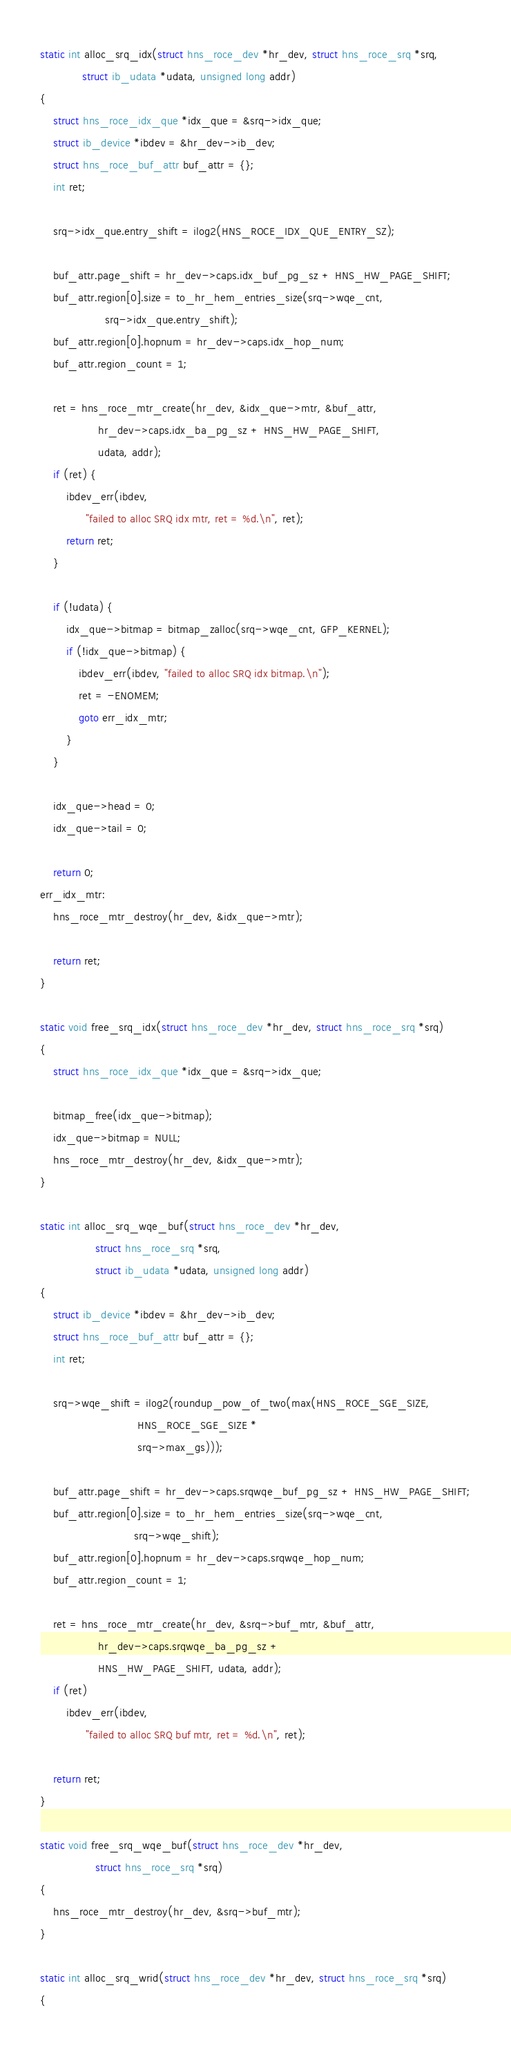<code> <loc_0><loc_0><loc_500><loc_500><_C_>
static int alloc_srq_idx(struct hns_roce_dev *hr_dev, struct hns_roce_srq *srq,
			 struct ib_udata *udata, unsigned long addr)
{
	struct hns_roce_idx_que *idx_que = &srq->idx_que;
	struct ib_device *ibdev = &hr_dev->ib_dev;
	struct hns_roce_buf_attr buf_attr = {};
	int ret;

	srq->idx_que.entry_shift = ilog2(HNS_ROCE_IDX_QUE_ENTRY_SZ);

	buf_attr.page_shift = hr_dev->caps.idx_buf_pg_sz + HNS_HW_PAGE_SHIFT;
	buf_attr.region[0].size = to_hr_hem_entries_size(srq->wqe_cnt,
					srq->idx_que.entry_shift);
	buf_attr.region[0].hopnum = hr_dev->caps.idx_hop_num;
	buf_attr.region_count = 1;

	ret = hns_roce_mtr_create(hr_dev, &idx_que->mtr, &buf_attr,
				  hr_dev->caps.idx_ba_pg_sz + HNS_HW_PAGE_SHIFT,
				  udata, addr);
	if (ret) {
		ibdev_err(ibdev,
			  "failed to alloc SRQ idx mtr, ret = %d.\n", ret);
		return ret;
	}

	if (!udata) {
		idx_que->bitmap = bitmap_zalloc(srq->wqe_cnt, GFP_KERNEL);
		if (!idx_que->bitmap) {
			ibdev_err(ibdev, "failed to alloc SRQ idx bitmap.\n");
			ret = -ENOMEM;
			goto err_idx_mtr;
		}
	}

	idx_que->head = 0;
	idx_que->tail = 0;

	return 0;
err_idx_mtr:
	hns_roce_mtr_destroy(hr_dev, &idx_que->mtr);

	return ret;
}

static void free_srq_idx(struct hns_roce_dev *hr_dev, struct hns_roce_srq *srq)
{
	struct hns_roce_idx_que *idx_que = &srq->idx_que;

	bitmap_free(idx_que->bitmap);
	idx_que->bitmap = NULL;
	hns_roce_mtr_destroy(hr_dev, &idx_que->mtr);
}

static int alloc_srq_wqe_buf(struct hns_roce_dev *hr_dev,
			     struct hns_roce_srq *srq,
			     struct ib_udata *udata, unsigned long addr)
{
	struct ib_device *ibdev = &hr_dev->ib_dev;
	struct hns_roce_buf_attr buf_attr = {};
	int ret;

	srq->wqe_shift = ilog2(roundup_pow_of_two(max(HNS_ROCE_SGE_SIZE,
						      HNS_ROCE_SGE_SIZE *
						      srq->max_gs)));

	buf_attr.page_shift = hr_dev->caps.srqwqe_buf_pg_sz + HNS_HW_PAGE_SHIFT;
	buf_attr.region[0].size = to_hr_hem_entries_size(srq->wqe_cnt,
							 srq->wqe_shift);
	buf_attr.region[0].hopnum = hr_dev->caps.srqwqe_hop_num;
	buf_attr.region_count = 1;

	ret = hns_roce_mtr_create(hr_dev, &srq->buf_mtr, &buf_attr,
				  hr_dev->caps.srqwqe_ba_pg_sz +
				  HNS_HW_PAGE_SHIFT, udata, addr);
	if (ret)
		ibdev_err(ibdev,
			  "failed to alloc SRQ buf mtr, ret = %d.\n", ret);

	return ret;
}

static void free_srq_wqe_buf(struct hns_roce_dev *hr_dev,
			     struct hns_roce_srq *srq)
{
	hns_roce_mtr_destroy(hr_dev, &srq->buf_mtr);
}

static int alloc_srq_wrid(struct hns_roce_dev *hr_dev, struct hns_roce_srq *srq)
{</code> 